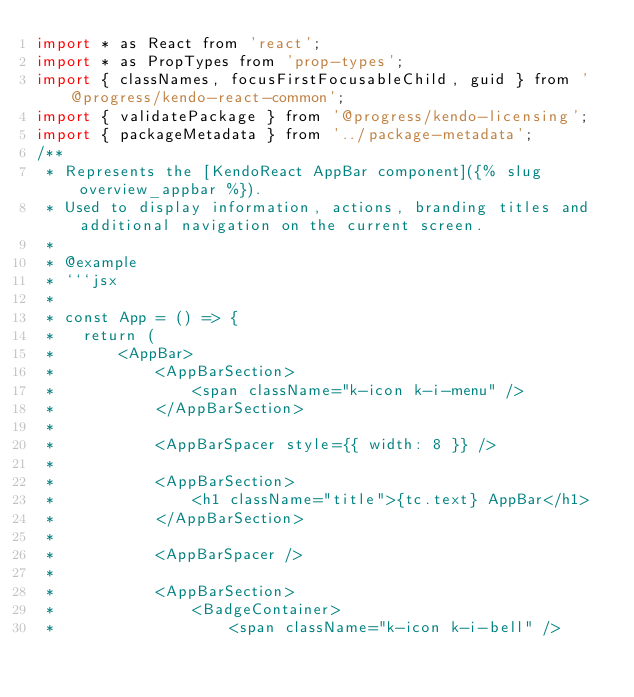<code> <loc_0><loc_0><loc_500><loc_500><_JavaScript_>import * as React from 'react';
import * as PropTypes from 'prop-types';
import { classNames, focusFirstFocusableChild, guid } from '@progress/kendo-react-common';
import { validatePackage } from '@progress/kendo-licensing';
import { packageMetadata } from '../package-metadata';
/**
 * Represents the [KendoReact AppBar component]({% slug overview_appbar %}).
 * Used to display information, actions, branding titles and additional navigation on the current screen.
 *
 * @example
 * ```jsx
 *
 * const App = () => {
 *   return (
 *       <AppBar>
 *           <AppBarSection>
 *               <span className="k-icon k-i-menu" />
 *           </AppBarSection>
 *
 *           <AppBarSpacer style={{ width: 8 }} />
 *
 *           <AppBarSection>
 *               <h1 className="title">{tc.text} AppBar</h1>
 *           </AppBarSection>
 *
 *           <AppBarSpacer />
 *
 *           <AppBarSection>
 *               <BadgeContainer>
 *                   <span className="k-icon k-i-bell" /></code> 